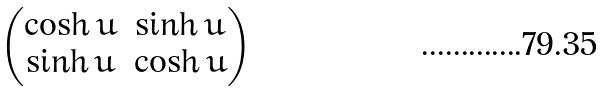<formula> <loc_0><loc_0><loc_500><loc_500>\begin{pmatrix} \cosh u & \sinh u \\ \sinh u & \cosh u \end{pmatrix}</formula> 